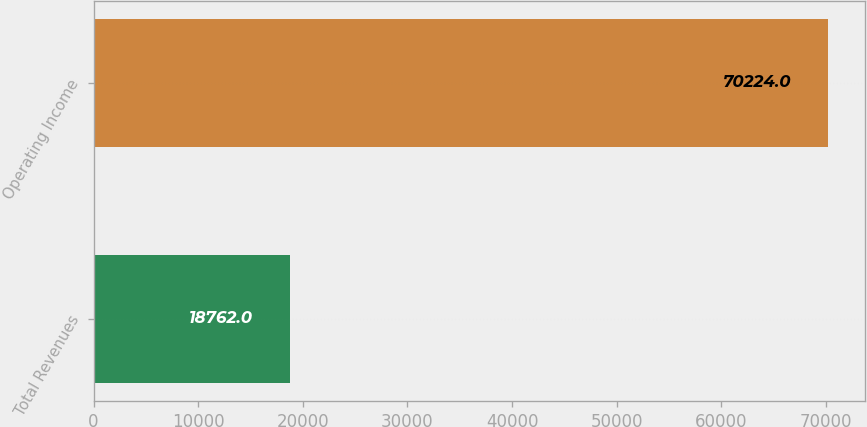Convert chart. <chart><loc_0><loc_0><loc_500><loc_500><bar_chart><fcel>Total Revenues<fcel>Operating Income<nl><fcel>18762<fcel>70224<nl></chart> 